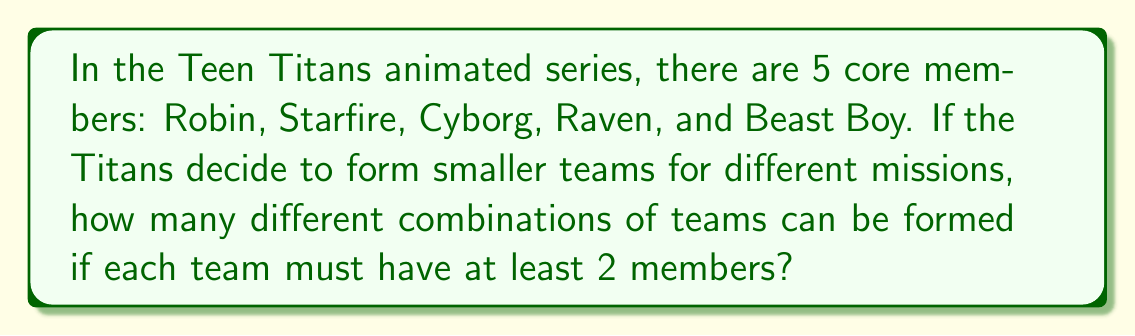Teach me how to tackle this problem. To solve this problem, we need to use the concept of combinations from discrete mathematics. We'll calculate the number of possible teams for each team size (2, 3, 4, and 5 members) and then sum them up.

1) For teams of 2 members:
   We use the combination formula: $C(5,2) = \frac{5!}{2!(5-2)!} = \frac{5 \cdot 4}{2 \cdot 1} = 10$

2) For teams of 3 members:
   $C(5,3) = \frac{5!}{3!(5-3)!} = \frac{5 \cdot 4 \cdot 3}{3 \cdot 2 \cdot 1} = 10$

3) For teams of 4 members:
   $C(5,4) = \frac{5!}{4!(5-4)!} = \frac{5}{1} = 5$

4) For teams of 5 members:
   $C(5,5) = \frac{5!}{5!(5-5)!} = 1$

Now, we sum up all these possibilities:

$$\sum_{k=2}^5 C(5,k) = C(5,2) + C(5,3) + C(5,4) + C(5,5) = 10 + 10 + 5 + 1 = 26$$

Therefore, the total number of possible team combinations is 26.
Answer: 26 possible team combinations 